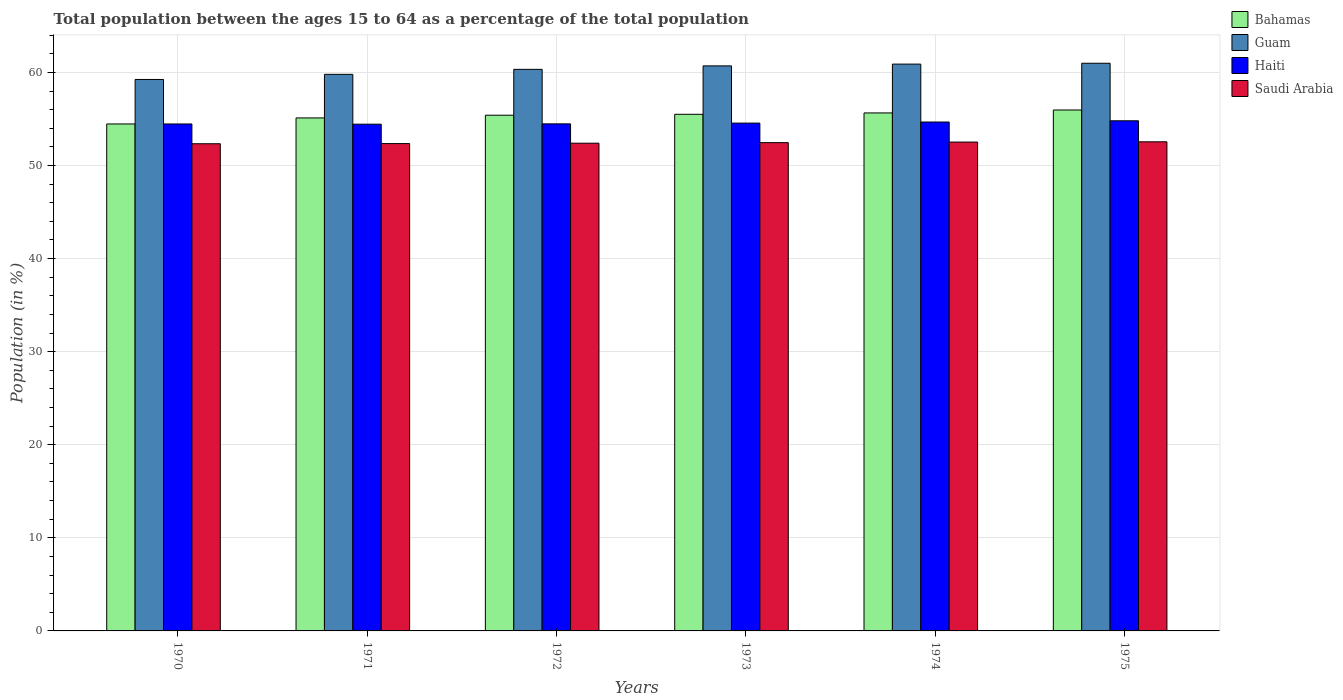Are the number of bars on each tick of the X-axis equal?
Your response must be concise. Yes. How many bars are there on the 2nd tick from the left?
Offer a very short reply. 4. What is the label of the 2nd group of bars from the left?
Your response must be concise. 1971. What is the percentage of the population ages 15 to 64 in Haiti in 1971?
Your response must be concise. 54.44. Across all years, what is the maximum percentage of the population ages 15 to 64 in Guam?
Provide a succinct answer. 60.98. Across all years, what is the minimum percentage of the population ages 15 to 64 in Guam?
Your answer should be compact. 59.24. In which year was the percentage of the population ages 15 to 64 in Haiti maximum?
Offer a very short reply. 1975. What is the total percentage of the population ages 15 to 64 in Haiti in the graph?
Give a very brief answer. 327.39. What is the difference between the percentage of the population ages 15 to 64 in Haiti in 1974 and that in 1975?
Ensure brevity in your answer.  -0.13. What is the difference between the percentage of the population ages 15 to 64 in Haiti in 1972 and the percentage of the population ages 15 to 64 in Bahamas in 1971?
Your answer should be compact. -0.64. What is the average percentage of the population ages 15 to 64 in Guam per year?
Offer a very short reply. 60.32. In the year 1972, what is the difference between the percentage of the population ages 15 to 64 in Haiti and percentage of the population ages 15 to 64 in Saudi Arabia?
Offer a very short reply. 2.08. In how many years, is the percentage of the population ages 15 to 64 in Saudi Arabia greater than 16?
Offer a very short reply. 6. What is the ratio of the percentage of the population ages 15 to 64 in Guam in 1972 to that in 1974?
Make the answer very short. 0.99. What is the difference between the highest and the second highest percentage of the population ages 15 to 64 in Haiti?
Offer a very short reply. 0.13. What is the difference between the highest and the lowest percentage of the population ages 15 to 64 in Saudi Arabia?
Provide a succinct answer. 0.21. In how many years, is the percentage of the population ages 15 to 64 in Guam greater than the average percentage of the population ages 15 to 64 in Guam taken over all years?
Provide a short and direct response. 4. What does the 1st bar from the left in 1970 represents?
Your answer should be compact. Bahamas. What does the 4th bar from the right in 1970 represents?
Your answer should be very brief. Bahamas. How many bars are there?
Provide a short and direct response. 24. What is the difference between two consecutive major ticks on the Y-axis?
Your answer should be compact. 10. Are the values on the major ticks of Y-axis written in scientific E-notation?
Offer a very short reply. No. How many legend labels are there?
Give a very brief answer. 4. How are the legend labels stacked?
Offer a very short reply. Vertical. What is the title of the graph?
Provide a succinct answer. Total population between the ages 15 to 64 as a percentage of the total population. What is the label or title of the X-axis?
Ensure brevity in your answer.  Years. What is the Population (in %) of Bahamas in 1970?
Your answer should be compact. 54.46. What is the Population (in %) of Guam in 1970?
Make the answer very short. 59.24. What is the Population (in %) in Haiti in 1970?
Provide a succinct answer. 54.46. What is the Population (in %) in Saudi Arabia in 1970?
Provide a succinct answer. 52.33. What is the Population (in %) in Bahamas in 1971?
Your response must be concise. 55.11. What is the Population (in %) in Guam in 1971?
Offer a terse response. 59.79. What is the Population (in %) in Haiti in 1971?
Offer a terse response. 54.44. What is the Population (in %) in Saudi Arabia in 1971?
Your answer should be compact. 52.35. What is the Population (in %) in Bahamas in 1972?
Offer a terse response. 55.4. What is the Population (in %) of Guam in 1972?
Offer a terse response. 60.33. What is the Population (in %) in Haiti in 1972?
Your response must be concise. 54.47. What is the Population (in %) in Saudi Arabia in 1972?
Provide a short and direct response. 52.39. What is the Population (in %) in Bahamas in 1973?
Provide a succinct answer. 55.5. What is the Population (in %) in Guam in 1973?
Your answer should be compact. 60.7. What is the Population (in %) of Haiti in 1973?
Provide a short and direct response. 54.55. What is the Population (in %) in Saudi Arabia in 1973?
Keep it short and to the point. 52.45. What is the Population (in %) of Bahamas in 1974?
Give a very brief answer. 55.64. What is the Population (in %) of Guam in 1974?
Ensure brevity in your answer.  60.89. What is the Population (in %) in Haiti in 1974?
Your answer should be compact. 54.67. What is the Population (in %) in Saudi Arabia in 1974?
Your answer should be compact. 52.51. What is the Population (in %) in Bahamas in 1975?
Give a very brief answer. 55.96. What is the Population (in %) in Guam in 1975?
Give a very brief answer. 60.98. What is the Population (in %) of Haiti in 1975?
Offer a very short reply. 54.8. What is the Population (in %) of Saudi Arabia in 1975?
Provide a short and direct response. 52.54. Across all years, what is the maximum Population (in %) in Bahamas?
Give a very brief answer. 55.96. Across all years, what is the maximum Population (in %) of Guam?
Give a very brief answer. 60.98. Across all years, what is the maximum Population (in %) in Haiti?
Provide a short and direct response. 54.8. Across all years, what is the maximum Population (in %) of Saudi Arabia?
Offer a very short reply. 52.54. Across all years, what is the minimum Population (in %) in Bahamas?
Your answer should be very brief. 54.46. Across all years, what is the minimum Population (in %) of Guam?
Ensure brevity in your answer.  59.24. Across all years, what is the minimum Population (in %) in Haiti?
Your response must be concise. 54.44. Across all years, what is the minimum Population (in %) of Saudi Arabia?
Provide a short and direct response. 52.33. What is the total Population (in %) of Bahamas in the graph?
Give a very brief answer. 332.07. What is the total Population (in %) of Guam in the graph?
Your answer should be compact. 361.93. What is the total Population (in %) in Haiti in the graph?
Offer a very short reply. 327.39. What is the total Population (in %) of Saudi Arabia in the graph?
Ensure brevity in your answer.  314.59. What is the difference between the Population (in %) in Bahamas in 1970 and that in 1971?
Ensure brevity in your answer.  -0.65. What is the difference between the Population (in %) of Guam in 1970 and that in 1971?
Give a very brief answer. -0.55. What is the difference between the Population (in %) of Haiti in 1970 and that in 1971?
Keep it short and to the point. 0.02. What is the difference between the Population (in %) in Saudi Arabia in 1970 and that in 1971?
Offer a terse response. -0.02. What is the difference between the Population (in %) of Bahamas in 1970 and that in 1972?
Offer a terse response. -0.94. What is the difference between the Population (in %) of Guam in 1970 and that in 1972?
Offer a terse response. -1.09. What is the difference between the Population (in %) in Haiti in 1970 and that in 1972?
Provide a short and direct response. -0.01. What is the difference between the Population (in %) in Saudi Arabia in 1970 and that in 1972?
Offer a terse response. -0.06. What is the difference between the Population (in %) in Bahamas in 1970 and that in 1973?
Offer a very short reply. -1.04. What is the difference between the Population (in %) of Guam in 1970 and that in 1973?
Offer a terse response. -1.46. What is the difference between the Population (in %) in Haiti in 1970 and that in 1973?
Your response must be concise. -0.09. What is the difference between the Population (in %) of Saudi Arabia in 1970 and that in 1973?
Offer a terse response. -0.12. What is the difference between the Population (in %) of Bahamas in 1970 and that in 1974?
Your answer should be very brief. -1.18. What is the difference between the Population (in %) in Guam in 1970 and that in 1974?
Your answer should be compact. -1.65. What is the difference between the Population (in %) of Haiti in 1970 and that in 1974?
Your answer should be very brief. -0.21. What is the difference between the Population (in %) in Saudi Arabia in 1970 and that in 1974?
Your response must be concise. -0.18. What is the difference between the Population (in %) in Bahamas in 1970 and that in 1975?
Offer a terse response. -1.5. What is the difference between the Population (in %) of Guam in 1970 and that in 1975?
Give a very brief answer. -1.74. What is the difference between the Population (in %) of Haiti in 1970 and that in 1975?
Give a very brief answer. -0.34. What is the difference between the Population (in %) of Saudi Arabia in 1970 and that in 1975?
Give a very brief answer. -0.21. What is the difference between the Population (in %) of Bahamas in 1971 and that in 1972?
Ensure brevity in your answer.  -0.29. What is the difference between the Population (in %) in Guam in 1971 and that in 1972?
Provide a short and direct response. -0.53. What is the difference between the Population (in %) of Haiti in 1971 and that in 1972?
Your response must be concise. -0.03. What is the difference between the Population (in %) in Saudi Arabia in 1971 and that in 1972?
Give a very brief answer. -0.04. What is the difference between the Population (in %) of Bahamas in 1971 and that in 1973?
Make the answer very short. -0.39. What is the difference between the Population (in %) of Guam in 1971 and that in 1973?
Offer a terse response. -0.91. What is the difference between the Population (in %) of Haiti in 1971 and that in 1973?
Your response must be concise. -0.12. What is the difference between the Population (in %) in Saudi Arabia in 1971 and that in 1973?
Give a very brief answer. -0.1. What is the difference between the Population (in %) of Bahamas in 1971 and that in 1974?
Your response must be concise. -0.54. What is the difference between the Population (in %) in Guam in 1971 and that in 1974?
Offer a very short reply. -1.1. What is the difference between the Population (in %) of Haiti in 1971 and that in 1974?
Your answer should be compact. -0.23. What is the difference between the Population (in %) in Saudi Arabia in 1971 and that in 1974?
Make the answer very short. -0.16. What is the difference between the Population (in %) in Bahamas in 1971 and that in 1975?
Your answer should be very brief. -0.85. What is the difference between the Population (in %) of Guam in 1971 and that in 1975?
Offer a very short reply. -1.19. What is the difference between the Population (in %) in Haiti in 1971 and that in 1975?
Offer a terse response. -0.36. What is the difference between the Population (in %) of Saudi Arabia in 1971 and that in 1975?
Provide a succinct answer. -0.19. What is the difference between the Population (in %) of Bahamas in 1972 and that in 1973?
Provide a short and direct response. -0.1. What is the difference between the Population (in %) of Guam in 1972 and that in 1973?
Provide a short and direct response. -0.37. What is the difference between the Population (in %) in Haiti in 1972 and that in 1973?
Keep it short and to the point. -0.08. What is the difference between the Population (in %) in Saudi Arabia in 1972 and that in 1973?
Your answer should be very brief. -0.06. What is the difference between the Population (in %) in Bahamas in 1972 and that in 1974?
Your answer should be very brief. -0.25. What is the difference between the Population (in %) of Guam in 1972 and that in 1974?
Provide a succinct answer. -0.56. What is the difference between the Population (in %) of Haiti in 1972 and that in 1974?
Offer a terse response. -0.2. What is the difference between the Population (in %) in Saudi Arabia in 1972 and that in 1974?
Make the answer very short. -0.12. What is the difference between the Population (in %) in Bahamas in 1972 and that in 1975?
Your response must be concise. -0.56. What is the difference between the Population (in %) of Guam in 1972 and that in 1975?
Your answer should be very brief. -0.66. What is the difference between the Population (in %) in Haiti in 1972 and that in 1975?
Provide a succinct answer. -0.33. What is the difference between the Population (in %) in Saudi Arabia in 1972 and that in 1975?
Provide a short and direct response. -0.15. What is the difference between the Population (in %) in Bahamas in 1973 and that in 1974?
Provide a succinct answer. -0.15. What is the difference between the Population (in %) of Guam in 1973 and that in 1974?
Provide a short and direct response. -0.19. What is the difference between the Population (in %) of Haiti in 1973 and that in 1974?
Keep it short and to the point. -0.12. What is the difference between the Population (in %) in Saudi Arabia in 1973 and that in 1974?
Offer a very short reply. -0.06. What is the difference between the Population (in %) of Bahamas in 1973 and that in 1975?
Provide a succinct answer. -0.46. What is the difference between the Population (in %) in Guam in 1973 and that in 1975?
Your answer should be very brief. -0.28. What is the difference between the Population (in %) of Haiti in 1973 and that in 1975?
Provide a short and direct response. -0.25. What is the difference between the Population (in %) in Saudi Arabia in 1973 and that in 1975?
Offer a terse response. -0.09. What is the difference between the Population (in %) in Bahamas in 1974 and that in 1975?
Ensure brevity in your answer.  -0.32. What is the difference between the Population (in %) of Guam in 1974 and that in 1975?
Your answer should be compact. -0.09. What is the difference between the Population (in %) of Haiti in 1974 and that in 1975?
Your answer should be very brief. -0.13. What is the difference between the Population (in %) in Saudi Arabia in 1974 and that in 1975?
Provide a short and direct response. -0.03. What is the difference between the Population (in %) of Bahamas in 1970 and the Population (in %) of Guam in 1971?
Your answer should be compact. -5.33. What is the difference between the Population (in %) in Bahamas in 1970 and the Population (in %) in Haiti in 1971?
Offer a terse response. 0.02. What is the difference between the Population (in %) in Bahamas in 1970 and the Population (in %) in Saudi Arabia in 1971?
Your answer should be very brief. 2.11. What is the difference between the Population (in %) of Guam in 1970 and the Population (in %) of Haiti in 1971?
Your response must be concise. 4.8. What is the difference between the Population (in %) in Guam in 1970 and the Population (in %) in Saudi Arabia in 1971?
Make the answer very short. 6.89. What is the difference between the Population (in %) of Haiti in 1970 and the Population (in %) of Saudi Arabia in 1971?
Offer a terse response. 2.11. What is the difference between the Population (in %) of Bahamas in 1970 and the Population (in %) of Guam in 1972?
Ensure brevity in your answer.  -5.87. What is the difference between the Population (in %) in Bahamas in 1970 and the Population (in %) in Haiti in 1972?
Make the answer very short. -0.01. What is the difference between the Population (in %) of Bahamas in 1970 and the Population (in %) of Saudi Arabia in 1972?
Ensure brevity in your answer.  2.07. What is the difference between the Population (in %) in Guam in 1970 and the Population (in %) in Haiti in 1972?
Your answer should be very brief. 4.77. What is the difference between the Population (in %) of Guam in 1970 and the Population (in %) of Saudi Arabia in 1972?
Make the answer very short. 6.85. What is the difference between the Population (in %) of Haiti in 1970 and the Population (in %) of Saudi Arabia in 1972?
Provide a succinct answer. 2.07. What is the difference between the Population (in %) of Bahamas in 1970 and the Population (in %) of Guam in 1973?
Provide a short and direct response. -6.24. What is the difference between the Population (in %) in Bahamas in 1970 and the Population (in %) in Haiti in 1973?
Provide a succinct answer. -0.09. What is the difference between the Population (in %) in Bahamas in 1970 and the Population (in %) in Saudi Arabia in 1973?
Offer a very short reply. 2.01. What is the difference between the Population (in %) of Guam in 1970 and the Population (in %) of Haiti in 1973?
Give a very brief answer. 4.69. What is the difference between the Population (in %) of Guam in 1970 and the Population (in %) of Saudi Arabia in 1973?
Your answer should be very brief. 6.79. What is the difference between the Population (in %) in Haiti in 1970 and the Population (in %) in Saudi Arabia in 1973?
Your answer should be very brief. 2.01. What is the difference between the Population (in %) of Bahamas in 1970 and the Population (in %) of Guam in 1974?
Your answer should be compact. -6.43. What is the difference between the Population (in %) of Bahamas in 1970 and the Population (in %) of Haiti in 1974?
Offer a very short reply. -0.21. What is the difference between the Population (in %) in Bahamas in 1970 and the Population (in %) in Saudi Arabia in 1974?
Keep it short and to the point. 1.95. What is the difference between the Population (in %) in Guam in 1970 and the Population (in %) in Haiti in 1974?
Provide a succinct answer. 4.57. What is the difference between the Population (in %) in Guam in 1970 and the Population (in %) in Saudi Arabia in 1974?
Make the answer very short. 6.72. What is the difference between the Population (in %) in Haiti in 1970 and the Population (in %) in Saudi Arabia in 1974?
Your response must be concise. 1.94. What is the difference between the Population (in %) in Bahamas in 1970 and the Population (in %) in Guam in 1975?
Ensure brevity in your answer.  -6.52. What is the difference between the Population (in %) in Bahamas in 1970 and the Population (in %) in Haiti in 1975?
Offer a terse response. -0.34. What is the difference between the Population (in %) of Bahamas in 1970 and the Population (in %) of Saudi Arabia in 1975?
Keep it short and to the point. 1.92. What is the difference between the Population (in %) in Guam in 1970 and the Population (in %) in Haiti in 1975?
Your answer should be compact. 4.44. What is the difference between the Population (in %) of Guam in 1970 and the Population (in %) of Saudi Arabia in 1975?
Offer a terse response. 6.7. What is the difference between the Population (in %) of Haiti in 1970 and the Population (in %) of Saudi Arabia in 1975?
Provide a succinct answer. 1.92. What is the difference between the Population (in %) of Bahamas in 1971 and the Population (in %) of Guam in 1972?
Ensure brevity in your answer.  -5.22. What is the difference between the Population (in %) in Bahamas in 1971 and the Population (in %) in Haiti in 1972?
Your response must be concise. 0.64. What is the difference between the Population (in %) of Bahamas in 1971 and the Population (in %) of Saudi Arabia in 1972?
Offer a very short reply. 2.71. What is the difference between the Population (in %) of Guam in 1971 and the Population (in %) of Haiti in 1972?
Make the answer very short. 5.32. What is the difference between the Population (in %) of Guam in 1971 and the Population (in %) of Saudi Arabia in 1972?
Ensure brevity in your answer.  7.4. What is the difference between the Population (in %) in Haiti in 1971 and the Population (in %) in Saudi Arabia in 1972?
Provide a short and direct response. 2.04. What is the difference between the Population (in %) of Bahamas in 1971 and the Population (in %) of Guam in 1973?
Make the answer very short. -5.59. What is the difference between the Population (in %) in Bahamas in 1971 and the Population (in %) in Haiti in 1973?
Provide a succinct answer. 0.56. What is the difference between the Population (in %) in Bahamas in 1971 and the Population (in %) in Saudi Arabia in 1973?
Your answer should be very brief. 2.65. What is the difference between the Population (in %) of Guam in 1971 and the Population (in %) of Haiti in 1973?
Ensure brevity in your answer.  5.24. What is the difference between the Population (in %) in Guam in 1971 and the Population (in %) in Saudi Arabia in 1973?
Offer a very short reply. 7.34. What is the difference between the Population (in %) in Haiti in 1971 and the Population (in %) in Saudi Arabia in 1973?
Offer a very short reply. 1.98. What is the difference between the Population (in %) of Bahamas in 1971 and the Population (in %) of Guam in 1974?
Ensure brevity in your answer.  -5.78. What is the difference between the Population (in %) in Bahamas in 1971 and the Population (in %) in Haiti in 1974?
Offer a terse response. 0.44. What is the difference between the Population (in %) of Bahamas in 1971 and the Population (in %) of Saudi Arabia in 1974?
Give a very brief answer. 2.59. What is the difference between the Population (in %) in Guam in 1971 and the Population (in %) in Haiti in 1974?
Offer a terse response. 5.12. What is the difference between the Population (in %) in Guam in 1971 and the Population (in %) in Saudi Arabia in 1974?
Your answer should be compact. 7.28. What is the difference between the Population (in %) of Haiti in 1971 and the Population (in %) of Saudi Arabia in 1974?
Ensure brevity in your answer.  1.92. What is the difference between the Population (in %) of Bahamas in 1971 and the Population (in %) of Guam in 1975?
Make the answer very short. -5.87. What is the difference between the Population (in %) in Bahamas in 1971 and the Population (in %) in Haiti in 1975?
Provide a succinct answer. 0.31. What is the difference between the Population (in %) in Bahamas in 1971 and the Population (in %) in Saudi Arabia in 1975?
Your answer should be compact. 2.56. What is the difference between the Population (in %) in Guam in 1971 and the Population (in %) in Haiti in 1975?
Provide a succinct answer. 4.99. What is the difference between the Population (in %) of Guam in 1971 and the Population (in %) of Saudi Arabia in 1975?
Provide a short and direct response. 7.25. What is the difference between the Population (in %) of Haiti in 1971 and the Population (in %) of Saudi Arabia in 1975?
Provide a succinct answer. 1.89. What is the difference between the Population (in %) in Bahamas in 1972 and the Population (in %) in Guam in 1973?
Keep it short and to the point. -5.3. What is the difference between the Population (in %) of Bahamas in 1972 and the Population (in %) of Haiti in 1973?
Keep it short and to the point. 0.85. What is the difference between the Population (in %) in Bahamas in 1972 and the Population (in %) in Saudi Arabia in 1973?
Offer a terse response. 2.95. What is the difference between the Population (in %) of Guam in 1972 and the Population (in %) of Haiti in 1973?
Provide a short and direct response. 5.77. What is the difference between the Population (in %) of Guam in 1972 and the Population (in %) of Saudi Arabia in 1973?
Give a very brief answer. 7.87. What is the difference between the Population (in %) in Haiti in 1972 and the Population (in %) in Saudi Arabia in 1973?
Offer a terse response. 2.02. What is the difference between the Population (in %) in Bahamas in 1972 and the Population (in %) in Guam in 1974?
Make the answer very short. -5.49. What is the difference between the Population (in %) in Bahamas in 1972 and the Population (in %) in Haiti in 1974?
Give a very brief answer. 0.73. What is the difference between the Population (in %) in Bahamas in 1972 and the Population (in %) in Saudi Arabia in 1974?
Give a very brief answer. 2.88. What is the difference between the Population (in %) of Guam in 1972 and the Population (in %) of Haiti in 1974?
Make the answer very short. 5.66. What is the difference between the Population (in %) in Guam in 1972 and the Population (in %) in Saudi Arabia in 1974?
Keep it short and to the point. 7.81. What is the difference between the Population (in %) of Haiti in 1972 and the Population (in %) of Saudi Arabia in 1974?
Make the answer very short. 1.96. What is the difference between the Population (in %) in Bahamas in 1972 and the Population (in %) in Guam in 1975?
Your answer should be compact. -5.58. What is the difference between the Population (in %) of Bahamas in 1972 and the Population (in %) of Haiti in 1975?
Provide a short and direct response. 0.6. What is the difference between the Population (in %) in Bahamas in 1972 and the Population (in %) in Saudi Arabia in 1975?
Offer a very short reply. 2.86. What is the difference between the Population (in %) of Guam in 1972 and the Population (in %) of Haiti in 1975?
Provide a short and direct response. 5.52. What is the difference between the Population (in %) in Guam in 1972 and the Population (in %) in Saudi Arabia in 1975?
Offer a very short reply. 7.78. What is the difference between the Population (in %) of Haiti in 1972 and the Population (in %) of Saudi Arabia in 1975?
Your response must be concise. 1.93. What is the difference between the Population (in %) in Bahamas in 1973 and the Population (in %) in Guam in 1974?
Give a very brief answer. -5.39. What is the difference between the Population (in %) in Bahamas in 1973 and the Population (in %) in Haiti in 1974?
Give a very brief answer. 0.83. What is the difference between the Population (in %) of Bahamas in 1973 and the Population (in %) of Saudi Arabia in 1974?
Give a very brief answer. 2.98. What is the difference between the Population (in %) of Guam in 1973 and the Population (in %) of Haiti in 1974?
Offer a terse response. 6.03. What is the difference between the Population (in %) of Guam in 1973 and the Population (in %) of Saudi Arabia in 1974?
Provide a succinct answer. 8.18. What is the difference between the Population (in %) in Haiti in 1973 and the Population (in %) in Saudi Arabia in 1974?
Keep it short and to the point. 2.04. What is the difference between the Population (in %) of Bahamas in 1973 and the Population (in %) of Guam in 1975?
Make the answer very short. -5.48. What is the difference between the Population (in %) in Bahamas in 1973 and the Population (in %) in Haiti in 1975?
Ensure brevity in your answer.  0.7. What is the difference between the Population (in %) of Bahamas in 1973 and the Population (in %) of Saudi Arabia in 1975?
Offer a very short reply. 2.95. What is the difference between the Population (in %) in Guam in 1973 and the Population (in %) in Haiti in 1975?
Offer a very short reply. 5.9. What is the difference between the Population (in %) of Guam in 1973 and the Population (in %) of Saudi Arabia in 1975?
Your response must be concise. 8.16. What is the difference between the Population (in %) in Haiti in 1973 and the Population (in %) in Saudi Arabia in 1975?
Make the answer very short. 2.01. What is the difference between the Population (in %) in Bahamas in 1974 and the Population (in %) in Guam in 1975?
Keep it short and to the point. -5.34. What is the difference between the Population (in %) of Bahamas in 1974 and the Population (in %) of Haiti in 1975?
Offer a very short reply. 0.84. What is the difference between the Population (in %) of Bahamas in 1974 and the Population (in %) of Saudi Arabia in 1975?
Ensure brevity in your answer.  3.1. What is the difference between the Population (in %) in Guam in 1974 and the Population (in %) in Haiti in 1975?
Provide a short and direct response. 6.09. What is the difference between the Population (in %) in Guam in 1974 and the Population (in %) in Saudi Arabia in 1975?
Provide a succinct answer. 8.35. What is the difference between the Population (in %) in Haiti in 1974 and the Population (in %) in Saudi Arabia in 1975?
Give a very brief answer. 2.12. What is the average Population (in %) in Bahamas per year?
Your answer should be very brief. 55.34. What is the average Population (in %) in Guam per year?
Provide a short and direct response. 60.32. What is the average Population (in %) of Haiti per year?
Ensure brevity in your answer.  54.56. What is the average Population (in %) of Saudi Arabia per year?
Give a very brief answer. 52.43. In the year 1970, what is the difference between the Population (in %) of Bahamas and Population (in %) of Guam?
Your answer should be compact. -4.78. In the year 1970, what is the difference between the Population (in %) of Bahamas and Population (in %) of Haiti?
Your answer should be very brief. 0. In the year 1970, what is the difference between the Population (in %) of Bahamas and Population (in %) of Saudi Arabia?
Offer a very short reply. 2.13. In the year 1970, what is the difference between the Population (in %) in Guam and Population (in %) in Haiti?
Provide a short and direct response. 4.78. In the year 1970, what is the difference between the Population (in %) of Guam and Population (in %) of Saudi Arabia?
Make the answer very short. 6.9. In the year 1970, what is the difference between the Population (in %) of Haiti and Population (in %) of Saudi Arabia?
Provide a short and direct response. 2.12. In the year 1971, what is the difference between the Population (in %) in Bahamas and Population (in %) in Guam?
Make the answer very short. -4.68. In the year 1971, what is the difference between the Population (in %) of Bahamas and Population (in %) of Haiti?
Make the answer very short. 0.67. In the year 1971, what is the difference between the Population (in %) in Bahamas and Population (in %) in Saudi Arabia?
Provide a short and direct response. 2.76. In the year 1971, what is the difference between the Population (in %) in Guam and Population (in %) in Haiti?
Provide a succinct answer. 5.36. In the year 1971, what is the difference between the Population (in %) in Guam and Population (in %) in Saudi Arabia?
Provide a short and direct response. 7.44. In the year 1971, what is the difference between the Population (in %) in Haiti and Population (in %) in Saudi Arabia?
Keep it short and to the point. 2.08. In the year 1972, what is the difference between the Population (in %) of Bahamas and Population (in %) of Guam?
Make the answer very short. -4.93. In the year 1972, what is the difference between the Population (in %) in Bahamas and Population (in %) in Haiti?
Provide a succinct answer. 0.93. In the year 1972, what is the difference between the Population (in %) in Bahamas and Population (in %) in Saudi Arabia?
Your response must be concise. 3.01. In the year 1972, what is the difference between the Population (in %) of Guam and Population (in %) of Haiti?
Provide a short and direct response. 5.85. In the year 1972, what is the difference between the Population (in %) of Guam and Population (in %) of Saudi Arabia?
Provide a succinct answer. 7.93. In the year 1972, what is the difference between the Population (in %) of Haiti and Population (in %) of Saudi Arabia?
Offer a terse response. 2.08. In the year 1973, what is the difference between the Population (in %) of Bahamas and Population (in %) of Guam?
Your response must be concise. -5.2. In the year 1973, what is the difference between the Population (in %) of Bahamas and Population (in %) of Haiti?
Offer a very short reply. 0.95. In the year 1973, what is the difference between the Population (in %) of Bahamas and Population (in %) of Saudi Arabia?
Provide a succinct answer. 3.04. In the year 1973, what is the difference between the Population (in %) of Guam and Population (in %) of Haiti?
Your answer should be very brief. 6.15. In the year 1973, what is the difference between the Population (in %) of Guam and Population (in %) of Saudi Arabia?
Give a very brief answer. 8.25. In the year 1973, what is the difference between the Population (in %) of Haiti and Population (in %) of Saudi Arabia?
Make the answer very short. 2.1. In the year 1974, what is the difference between the Population (in %) in Bahamas and Population (in %) in Guam?
Make the answer very short. -5.25. In the year 1974, what is the difference between the Population (in %) of Bahamas and Population (in %) of Haiti?
Your response must be concise. 0.98. In the year 1974, what is the difference between the Population (in %) in Bahamas and Population (in %) in Saudi Arabia?
Offer a very short reply. 3.13. In the year 1974, what is the difference between the Population (in %) in Guam and Population (in %) in Haiti?
Offer a terse response. 6.22. In the year 1974, what is the difference between the Population (in %) of Guam and Population (in %) of Saudi Arabia?
Provide a short and direct response. 8.38. In the year 1974, what is the difference between the Population (in %) in Haiti and Population (in %) in Saudi Arabia?
Give a very brief answer. 2.15. In the year 1975, what is the difference between the Population (in %) in Bahamas and Population (in %) in Guam?
Offer a terse response. -5.02. In the year 1975, what is the difference between the Population (in %) in Bahamas and Population (in %) in Haiti?
Keep it short and to the point. 1.16. In the year 1975, what is the difference between the Population (in %) of Bahamas and Population (in %) of Saudi Arabia?
Offer a very short reply. 3.42. In the year 1975, what is the difference between the Population (in %) of Guam and Population (in %) of Haiti?
Your answer should be very brief. 6.18. In the year 1975, what is the difference between the Population (in %) in Guam and Population (in %) in Saudi Arabia?
Your answer should be compact. 8.44. In the year 1975, what is the difference between the Population (in %) of Haiti and Population (in %) of Saudi Arabia?
Your answer should be compact. 2.26. What is the ratio of the Population (in %) in Bahamas in 1970 to that in 1971?
Give a very brief answer. 0.99. What is the ratio of the Population (in %) of Guam in 1970 to that in 1971?
Offer a very short reply. 0.99. What is the ratio of the Population (in %) of Haiti in 1970 to that in 1971?
Provide a short and direct response. 1. What is the ratio of the Population (in %) of Bahamas in 1970 to that in 1972?
Give a very brief answer. 0.98. What is the ratio of the Population (in %) in Guam in 1970 to that in 1972?
Your response must be concise. 0.98. What is the ratio of the Population (in %) of Haiti in 1970 to that in 1972?
Offer a very short reply. 1. What is the ratio of the Population (in %) of Bahamas in 1970 to that in 1973?
Provide a short and direct response. 0.98. What is the ratio of the Population (in %) in Guam in 1970 to that in 1973?
Provide a short and direct response. 0.98. What is the ratio of the Population (in %) of Saudi Arabia in 1970 to that in 1973?
Ensure brevity in your answer.  1. What is the ratio of the Population (in %) in Bahamas in 1970 to that in 1974?
Give a very brief answer. 0.98. What is the ratio of the Population (in %) of Guam in 1970 to that in 1974?
Your answer should be compact. 0.97. What is the ratio of the Population (in %) in Bahamas in 1970 to that in 1975?
Offer a terse response. 0.97. What is the ratio of the Population (in %) of Guam in 1970 to that in 1975?
Give a very brief answer. 0.97. What is the ratio of the Population (in %) in Saudi Arabia in 1970 to that in 1975?
Make the answer very short. 1. What is the ratio of the Population (in %) of Haiti in 1971 to that in 1972?
Offer a terse response. 1. What is the ratio of the Population (in %) in Bahamas in 1971 to that in 1973?
Provide a short and direct response. 0.99. What is the ratio of the Population (in %) of Guam in 1971 to that in 1973?
Your answer should be very brief. 0.99. What is the ratio of the Population (in %) of Haiti in 1971 to that in 1973?
Keep it short and to the point. 1. What is the ratio of the Population (in %) of Bahamas in 1971 to that in 1974?
Your answer should be compact. 0.99. What is the ratio of the Population (in %) in Guam in 1971 to that in 1974?
Make the answer very short. 0.98. What is the ratio of the Population (in %) in Haiti in 1971 to that in 1974?
Offer a very short reply. 1. What is the ratio of the Population (in %) of Saudi Arabia in 1971 to that in 1974?
Make the answer very short. 1. What is the ratio of the Population (in %) of Guam in 1971 to that in 1975?
Offer a terse response. 0.98. What is the ratio of the Population (in %) of Haiti in 1971 to that in 1975?
Your answer should be very brief. 0.99. What is the ratio of the Population (in %) in Guam in 1972 to that in 1973?
Your answer should be compact. 0.99. What is the ratio of the Population (in %) of Haiti in 1972 to that in 1973?
Your answer should be very brief. 1. What is the ratio of the Population (in %) of Saudi Arabia in 1972 to that in 1973?
Your response must be concise. 1. What is the ratio of the Population (in %) of Bahamas in 1972 to that in 1974?
Offer a terse response. 1. What is the ratio of the Population (in %) of Saudi Arabia in 1972 to that in 1974?
Offer a terse response. 1. What is the ratio of the Population (in %) of Guam in 1972 to that in 1975?
Your answer should be very brief. 0.99. What is the ratio of the Population (in %) in Haiti in 1972 to that in 1975?
Keep it short and to the point. 0.99. What is the ratio of the Population (in %) of Saudi Arabia in 1972 to that in 1975?
Offer a terse response. 1. What is the ratio of the Population (in %) in Bahamas in 1973 to that in 1974?
Your answer should be very brief. 1. What is the ratio of the Population (in %) of Haiti in 1973 to that in 1974?
Give a very brief answer. 1. What is the ratio of the Population (in %) of Saudi Arabia in 1973 to that in 1974?
Your answer should be compact. 1. What is the ratio of the Population (in %) in Bahamas in 1973 to that in 1975?
Your answer should be very brief. 0.99. What is the ratio of the Population (in %) of Guam in 1973 to that in 1975?
Provide a short and direct response. 1. What is the ratio of the Population (in %) in Bahamas in 1974 to that in 1975?
Your answer should be very brief. 0.99. What is the ratio of the Population (in %) in Guam in 1974 to that in 1975?
Provide a short and direct response. 1. What is the difference between the highest and the second highest Population (in %) of Bahamas?
Provide a succinct answer. 0.32. What is the difference between the highest and the second highest Population (in %) of Guam?
Keep it short and to the point. 0.09. What is the difference between the highest and the second highest Population (in %) in Haiti?
Provide a short and direct response. 0.13. What is the difference between the highest and the second highest Population (in %) in Saudi Arabia?
Make the answer very short. 0.03. What is the difference between the highest and the lowest Population (in %) in Bahamas?
Keep it short and to the point. 1.5. What is the difference between the highest and the lowest Population (in %) in Guam?
Your response must be concise. 1.74. What is the difference between the highest and the lowest Population (in %) of Haiti?
Offer a very short reply. 0.36. What is the difference between the highest and the lowest Population (in %) of Saudi Arabia?
Keep it short and to the point. 0.21. 